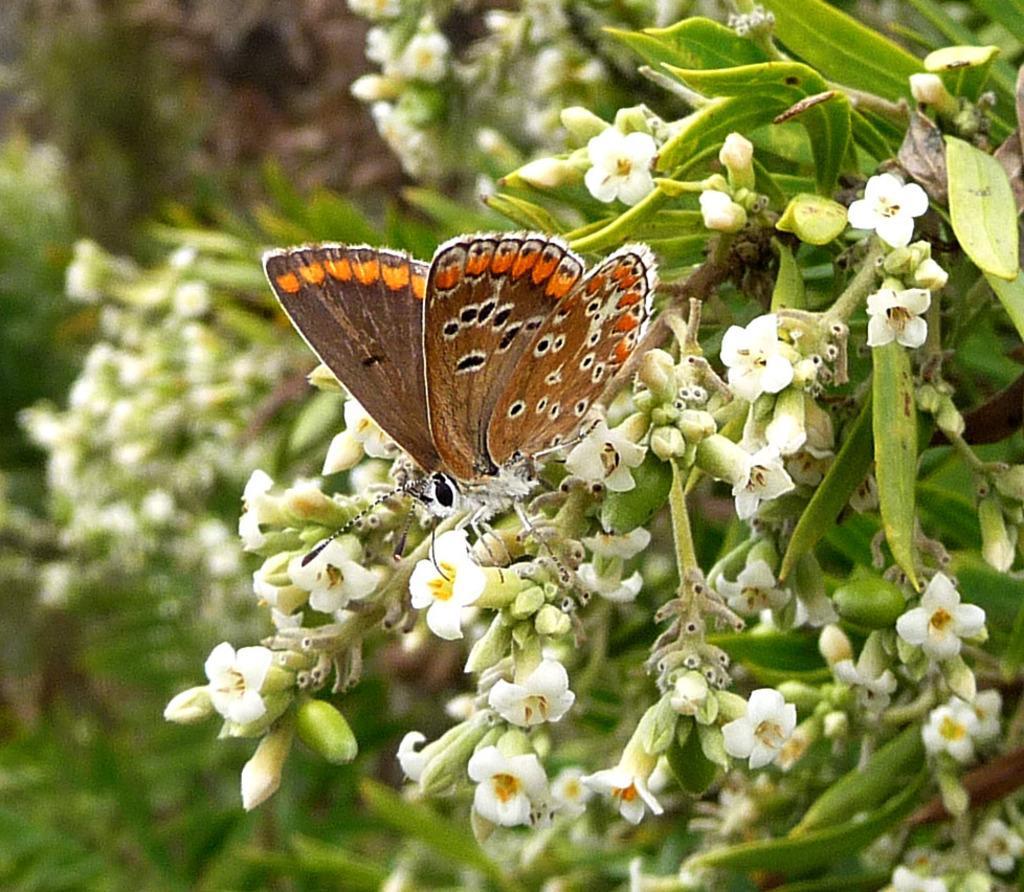How would you summarize this image in a sentence or two? The picture consists of plants, flowers and a butterfly. On the left it is blurred. 